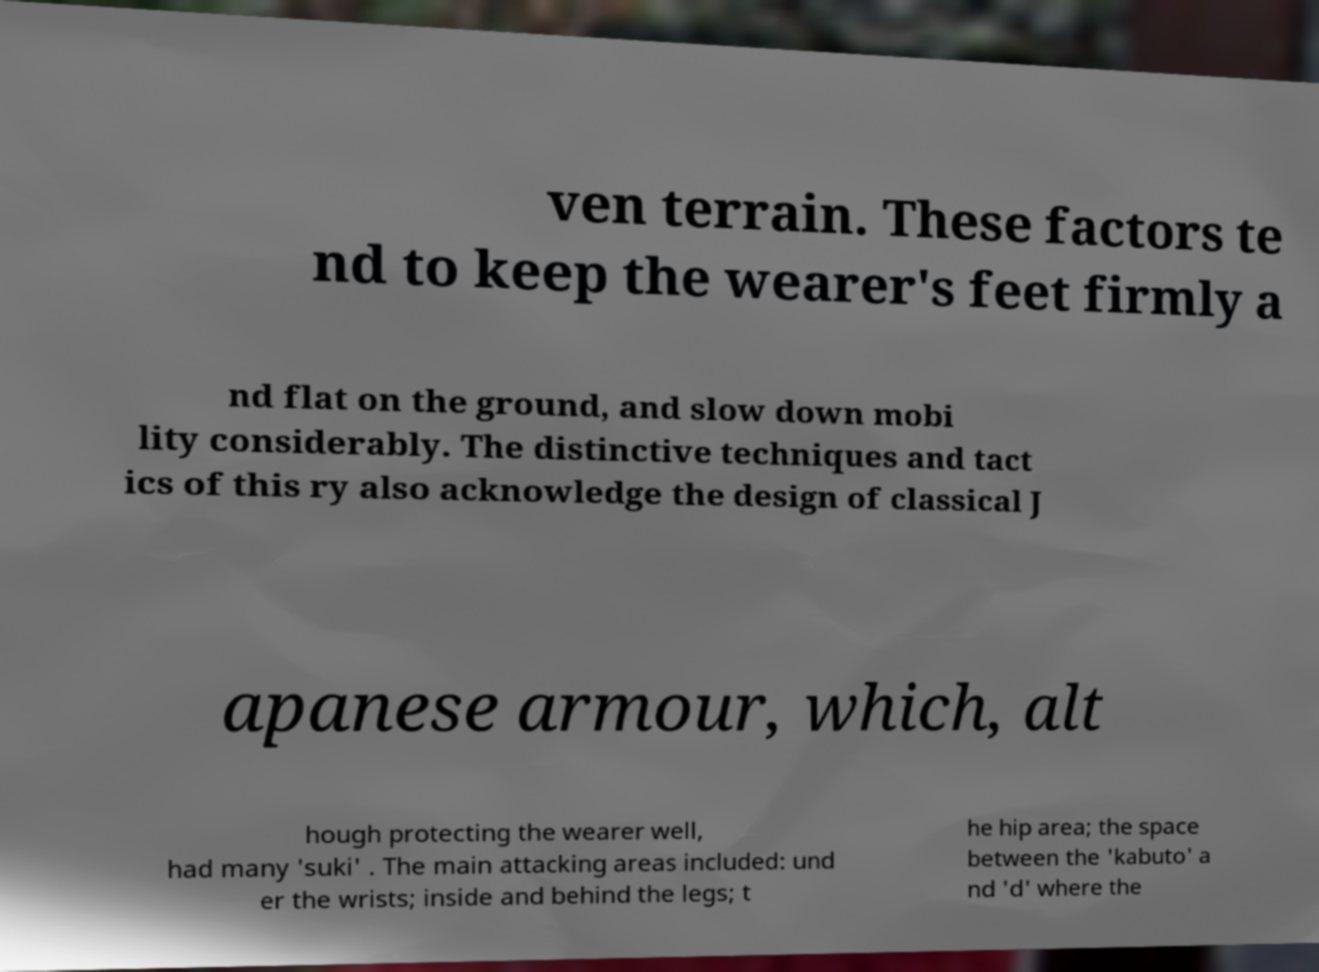Please identify and transcribe the text found in this image. ven terrain. These factors te nd to keep the wearer's feet firmly a nd flat on the ground, and slow down mobi lity considerably. The distinctive techniques and tact ics of this ry also acknowledge the design of classical J apanese armour, which, alt hough protecting the wearer well, had many 'suki' . The main attacking areas included: und er the wrists; inside and behind the legs; t he hip area; the space between the 'kabuto' a nd 'd' where the 